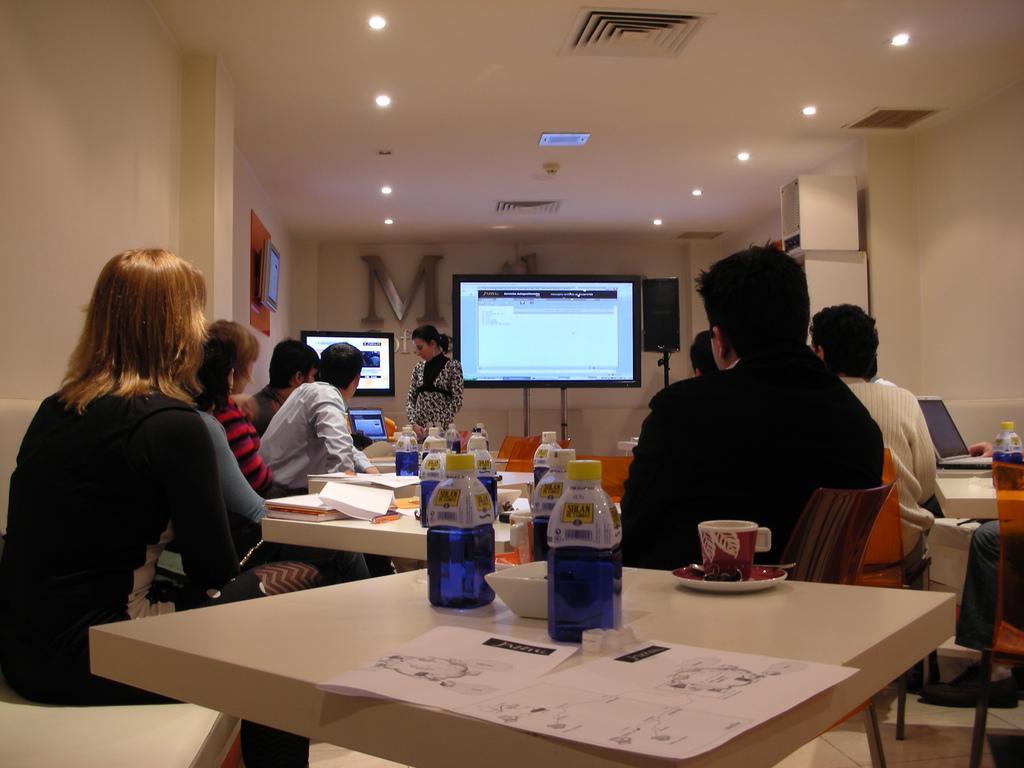Could you give a brief overview of what you see in this image? People are sitting on the chair on the table there is bottle,cap,saucier,paper and here there is television and here in the roof we have lights. 